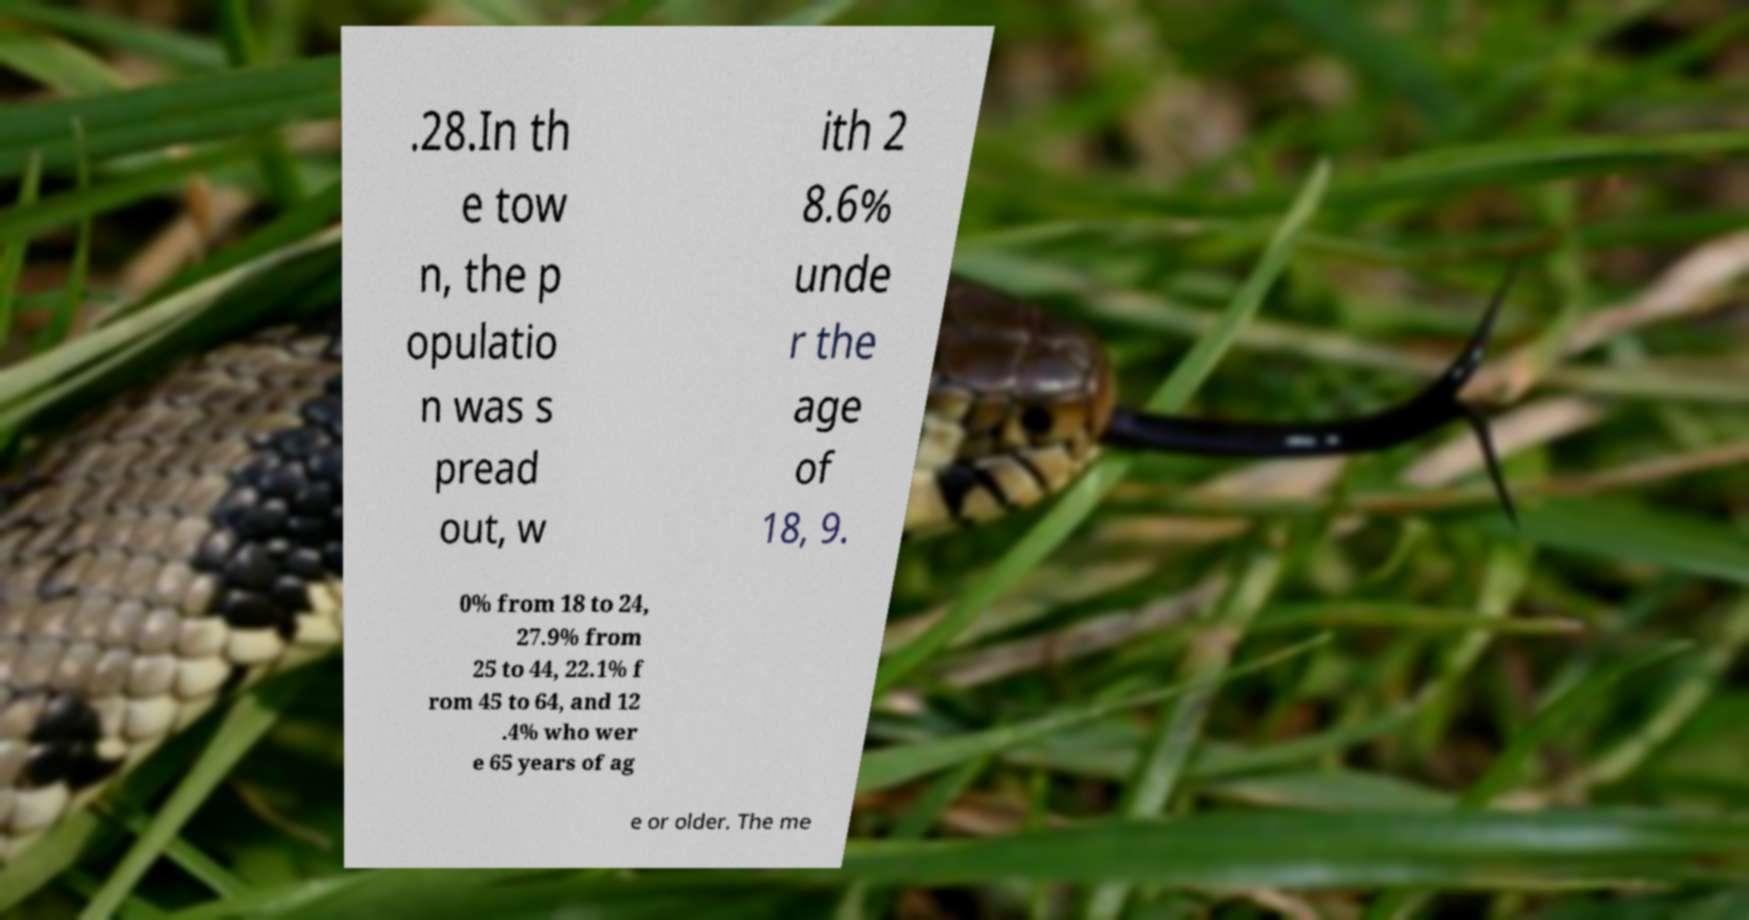Please identify and transcribe the text found in this image. .28.In th e tow n, the p opulatio n was s pread out, w ith 2 8.6% unde r the age of 18, 9. 0% from 18 to 24, 27.9% from 25 to 44, 22.1% f rom 45 to 64, and 12 .4% who wer e 65 years of ag e or older. The me 